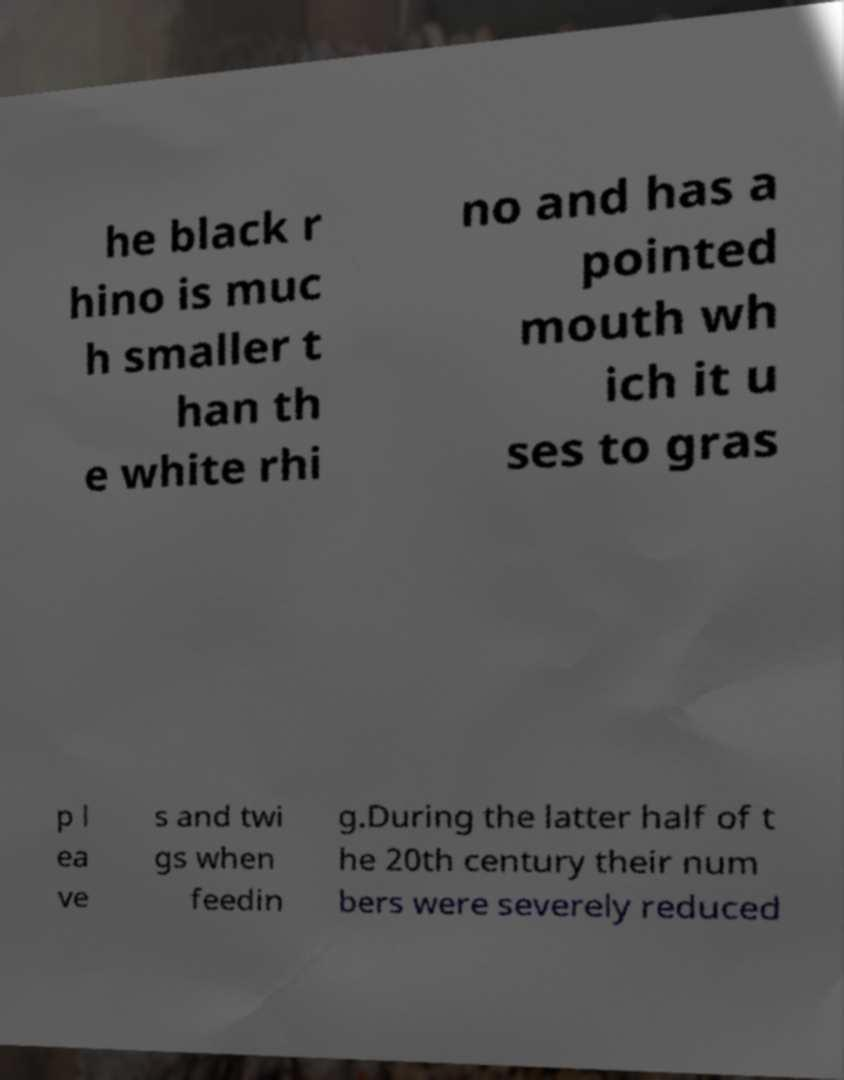Can you read and provide the text displayed in the image?This photo seems to have some interesting text. Can you extract and type it out for me? he black r hino is muc h smaller t han th e white rhi no and has a pointed mouth wh ich it u ses to gras p l ea ve s and twi gs when feedin g.During the latter half of t he 20th century their num bers were severely reduced 